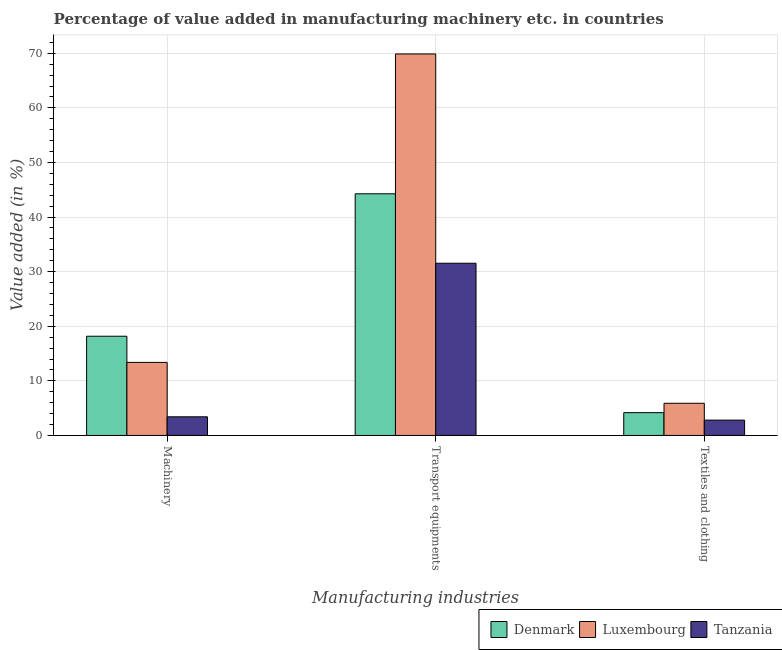How many different coloured bars are there?
Give a very brief answer. 3. Are the number of bars per tick equal to the number of legend labels?
Ensure brevity in your answer.  Yes. How many bars are there on the 3rd tick from the left?
Provide a succinct answer. 3. What is the label of the 1st group of bars from the left?
Your answer should be compact. Machinery. What is the value added in manufacturing transport equipments in Denmark?
Make the answer very short. 44.26. Across all countries, what is the maximum value added in manufacturing textile and clothing?
Keep it short and to the point. 5.89. Across all countries, what is the minimum value added in manufacturing machinery?
Give a very brief answer. 3.41. In which country was the value added in manufacturing textile and clothing maximum?
Offer a terse response. Luxembourg. In which country was the value added in manufacturing machinery minimum?
Provide a short and direct response. Tanzania. What is the total value added in manufacturing transport equipments in the graph?
Offer a very short reply. 145.69. What is the difference between the value added in manufacturing transport equipments in Denmark and that in Luxembourg?
Make the answer very short. -25.62. What is the difference between the value added in manufacturing transport equipments in Denmark and the value added in manufacturing machinery in Tanzania?
Offer a terse response. 40.85. What is the average value added in manufacturing transport equipments per country?
Keep it short and to the point. 48.56. What is the difference between the value added in manufacturing textile and clothing and value added in manufacturing machinery in Tanzania?
Offer a terse response. -0.61. In how many countries, is the value added in manufacturing transport equipments greater than 32 %?
Keep it short and to the point. 2. What is the ratio of the value added in manufacturing transport equipments in Denmark to that in Luxembourg?
Your response must be concise. 0.63. Is the difference between the value added in manufacturing machinery in Luxembourg and Denmark greater than the difference between the value added in manufacturing transport equipments in Luxembourg and Denmark?
Make the answer very short. No. What is the difference between the highest and the second highest value added in manufacturing transport equipments?
Keep it short and to the point. 25.62. What is the difference between the highest and the lowest value added in manufacturing textile and clothing?
Provide a succinct answer. 3.09. Is the sum of the value added in manufacturing machinery in Luxembourg and Denmark greater than the maximum value added in manufacturing transport equipments across all countries?
Your response must be concise. No. What does the 3rd bar from the left in Transport equipments represents?
Ensure brevity in your answer.  Tanzania. What does the 3rd bar from the right in Machinery represents?
Your answer should be very brief. Denmark. How many bars are there?
Offer a very short reply. 9. Does the graph contain any zero values?
Make the answer very short. No. What is the title of the graph?
Your answer should be compact. Percentage of value added in manufacturing machinery etc. in countries. Does "Uruguay" appear as one of the legend labels in the graph?
Provide a succinct answer. No. What is the label or title of the X-axis?
Keep it short and to the point. Manufacturing industries. What is the label or title of the Y-axis?
Ensure brevity in your answer.  Value added (in %). What is the Value added (in %) of Denmark in Machinery?
Offer a terse response. 18.17. What is the Value added (in %) in Luxembourg in Machinery?
Ensure brevity in your answer.  13.38. What is the Value added (in %) of Tanzania in Machinery?
Make the answer very short. 3.41. What is the Value added (in %) of Denmark in Transport equipments?
Your answer should be very brief. 44.26. What is the Value added (in %) of Luxembourg in Transport equipments?
Your response must be concise. 69.88. What is the Value added (in %) of Tanzania in Transport equipments?
Provide a succinct answer. 31.54. What is the Value added (in %) of Denmark in Textiles and clothing?
Provide a short and direct response. 4.17. What is the Value added (in %) of Luxembourg in Textiles and clothing?
Offer a terse response. 5.89. What is the Value added (in %) of Tanzania in Textiles and clothing?
Make the answer very short. 2.81. Across all Manufacturing industries, what is the maximum Value added (in %) of Denmark?
Provide a succinct answer. 44.26. Across all Manufacturing industries, what is the maximum Value added (in %) in Luxembourg?
Give a very brief answer. 69.88. Across all Manufacturing industries, what is the maximum Value added (in %) in Tanzania?
Offer a terse response. 31.54. Across all Manufacturing industries, what is the minimum Value added (in %) in Denmark?
Make the answer very short. 4.17. Across all Manufacturing industries, what is the minimum Value added (in %) of Luxembourg?
Make the answer very short. 5.89. Across all Manufacturing industries, what is the minimum Value added (in %) of Tanzania?
Ensure brevity in your answer.  2.81. What is the total Value added (in %) of Denmark in the graph?
Offer a very short reply. 66.61. What is the total Value added (in %) of Luxembourg in the graph?
Your response must be concise. 89.15. What is the total Value added (in %) in Tanzania in the graph?
Ensure brevity in your answer.  37.76. What is the difference between the Value added (in %) of Denmark in Machinery and that in Transport equipments?
Provide a short and direct response. -26.09. What is the difference between the Value added (in %) in Luxembourg in Machinery and that in Transport equipments?
Keep it short and to the point. -56.5. What is the difference between the Value added (in %) of Tanzania in Machinery and that in Transport equipments?
Offer a very short reply. -28.13. What is the difference between the Value added (in %) in Denmark in Machinery and that in Textiles and clothing?
Ensure brevity in your answer.  14. What is the difference between the Value added (in %) of Luxembourg in Machinery and that in Textiles and clothing?
Give a very brief answer. 7.49. What is the difference between the Value added (in %) in Tanzania in Machinery and that in Textiles and clothing?
Give a very brief answer. 0.61. What is the difference between the Value added (in %) of Denmark in Transport equipments and that in Textiles and clothing?
Give a very brief answer. 40.09. What is the difference between the Value added (in %) of Luxembourg in Transport equipments and that in Textiles and clothing?
Provide a succinct answer. 63.99. What is the difference between the Value added (in %) in Tanzania in Transport equipments and that in Textiles and clothing?
Provide a succinct answer. 28.74. What is the difference between the Value added (in %) of Denmark in Machinery and the Value added (in %) of Luxembourg in Transport equipments?
Your answer should be very brief. -51.71. What is the difference between the Value added (in %) in Denmark in Machinery and the Value added (in %) in Tanzania in Transport equipments?
Ensure brevity in your answer.  -13.37. What is the difference between the Value added (in %) in Luxembourg in Machinery and the Value added (in %) in Tanzania in Transport equipments?
Your answer should be compact. -18.16. What is the difference between the Value added (in %) in Denmark in Machinery and the Value added (in %) in Luxembourg in Textiles and clothing?
Ensure brevity in your answer.  12.28. What is the difference between the Value added (in %) of Denmark in Machinery and the Value added (in %) of Tanzania in Textiles and clothing?
Provide a succinct answer. 15.37. What is the difference between the Value added (in %) in Luxembourg in Machinery and the Value added (in %) in Tanzania in Textiles and clothing?
Provide a succinct answer. 10.57. What is the difference between the Value added (in %) in Denmark in Transport equipments and the Value added (in %) in Luxembourg in Textiles and clothing?
Keep it short and to the point. 38.37. What is the difference between the Value added (in %) in Denmark in Transport equipments and the Value added (in %) in Tanzania in Textiles and clothing?
Offer a very short reply. 41.46. What is the difference between the Value added (in %) of Luxembourg in Transport equipments and the Value added (in %) of Tanzania in Textiles and clothing?
Your answer should be compact. 67.07. What is the average Value added (in %) in Denmark per Manufacturing industries?
Your answer should be compact. 22.2. What is the average Value added (in %) of Luxembourg per Manufacturing industries?
Keep it short and to the point. 29.72. What is the average Value added (in %) in Tanzania per Manufacturing industries?
Keep it short and to the point. 12.59. What is the difference between the Value added (in %) of Denmark and Value added (in %) of Luxembourg in Machinery?
Keep it short and to the point. 4.8. What is the difference between the Value added (in %) of Denmark and Value added (in %) of Tanzania in Machinery?
Make the answer very short. 14.76. What is the difference between the Value added (in %) in Luxembourg and Value added (in %) in Tanzania in Machinery?
Keep it short and to the point. 9.96. What is the difference between the Value added (in %) in Denmark and Value added (in %) in Luxembourg in Transport equipments?
Provide a short and direct response. -25.62. What is the difference between the Value added (in %) in Denmark and Value added (in %) in Tanzania in Transport equipments?
Offer a terse response. 12.72. What is the difference between the Value added (in %) in Luxembourg and Value added (in %) in Tanzania in Transport equipments?
Offer a terse response. 38.34. What is the difference between the Value added (in %) in Denmark and Value added (in %) in Luxembourg in Textiles and clothing?
Your answer should be compact. -1.72. What is the difference between the Value added (in %) of Denmark and Value added (in %) of Tanzania in Textiles and clothing?
Your answer should be very brief. 1.36. What is the difference between the Value added (in %) of Luxembourg and Value added (in %) of Tanzania in Textiles and clothing?
Your answer should be very brief. 3.09. What is the ratio of the Value added (in %) in Denmark in Machinery to that in Transport equipments?
Make the answer very short. 0.41. What is the ratio of the Value added (in %) in Luxembourg in Machinery to that in Transport equipments?
Offer a very short reply. 0.19. What is the ratio of the Value added (in %) in Tanzania in Machinery to that in Transport equipments?
Offer a terse response. 0.11. What is the ratio of the Value added (in %) in Denmark in Machinery to that in Textiles and clothing?
Make the answer very short. 4.36. What is the ratio of the Value added (in %) of Luxembourg in Machinery to that in Textiles and clothing?
Provide a short and direct response. 2.27. What is the ratio of the Value added (in %) of Tanzania in Machinery to that in Textiles and clothing?
Offer a terse response. 1.22. What is the ratio of the Value added (in %) in Denmark in Transport equipments to that in Textiles and clothing?
Make the answer very short. 10.61. What is the ratio of the Value added (in %) of Luxembourg in Transport equipments to that in Textiles and clothing?
Provide a succinct answer. 11.86. What is the ratio of the Value added (in %) in Tanzania in Transport equipments to that in Textiles and clothing?
Your answer should be compact. 11.24. What is the difference between the highest and the second highest Value added (in %) in Denmark?
Make the answer very short. 26.09. What is the difference between the highest and the second highest Value added (in %) in Luxembourg?
Keep it short and to the point. 56.5. What is the difference between the highest and the second highest Value added (in %) in Tanzania?
Provide a short and direct response. 28.13. What is the difference between the highest and the lowest Value added (in %) of Denmark?
Provide a short and direct response. 40.09. What is the difference between the highest and the lowest Value added (in %) of Luxembourg?
Your answer should be compact. 63.99. What is the difference between the highest and the lowest Value added (in %) in Tanzania?
Keep it short and to the point. 28.74. 